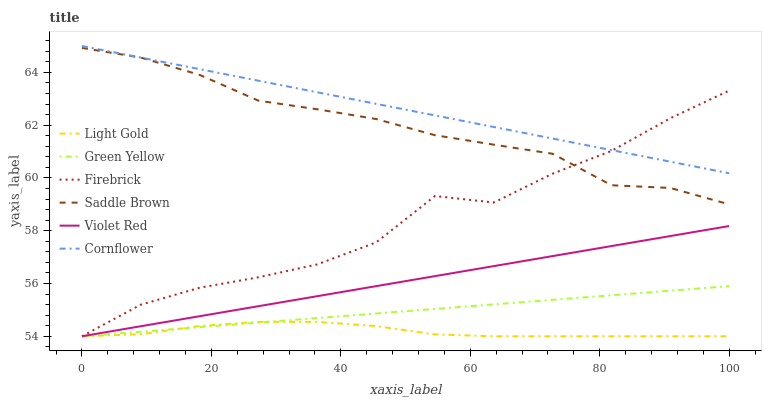Does Light Gold have the minimum area under the curve?
Answer yes or no. Yes. Does Cornflower have the maximum area under the curve?
Answer yes or no. Yes. Does Violet Red have the minimum area under the curve?
Answer yes or no. No. Does Violet Red have the maximum area under the curve?
Answer yes or no. No. Is Violet Red the smoothest?
Answer yes or no. Yes. Is Firebrick the roughest?
Answer yes or no. Yes. Is Firebrick the smoothest?
Answer yes or no. No. Is Violet Red the roughest?
Answer yes or no. No. Does Violet Red have the lowest value?
Answer yes or no. Yes. Does Saddle Brown have the lowest value?
Answer yes or no. No. Does Cornflower have the highest value?
Answer yes or no. Yes. Does Violet Red have the highest value?
Answer yes or no. No. Is Green Yellow less than Saddle Brown?
Answer yes or no. Yes. Is Cornflower greater than Green Yellow?
Answer yes or no. Yes. Does Light Gold intersect Violet Red?
Answer yes or no. Yes. Is Light Gold less than Violet Red?
Answer yes or no. No. Is Light Gold greater than Violet Red?
Answer yes or no. No. Does Green Yellow intersect Saddle Brown?
Answer yes or no. No. 